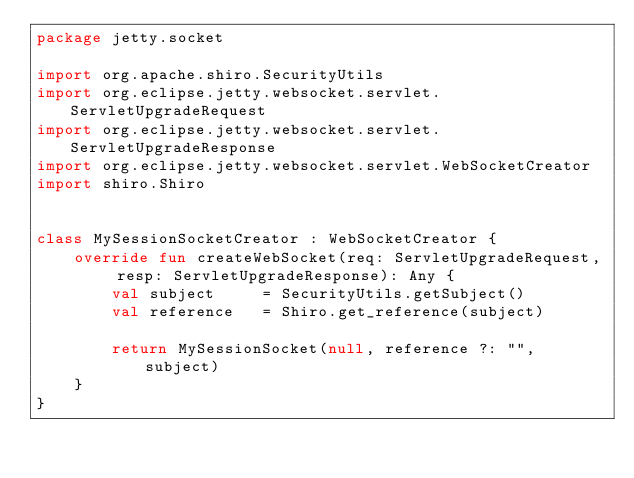<code> <loc_0><loc_0><loc_500><loc_500><_Kotlin_>package jetty.socket

import org.apache.shiro.SecurityUtils
import org.eclipse.jetty.websocket.servlet.ServletUpgradeRequest
import org.eclipse.jetty.websocket.servlet.ServletUpgradeResponse
import org.eclipse.jetty.websocket.servlet.WebSocketCreator
import shiro.Shiro


class MySessionSocketCreator : WebSocketCreator {
    override fun createWebSocket(req: ServletUpgradeRequest, resp: ServletUpgradeResponse): Any {
        val subject     = SecurityUtils.getSubject()
        val reference   = Shiro.get_reference(subject)

        return MySessionSocket(null, reference ?: "", subject)
    }
}
</code> 